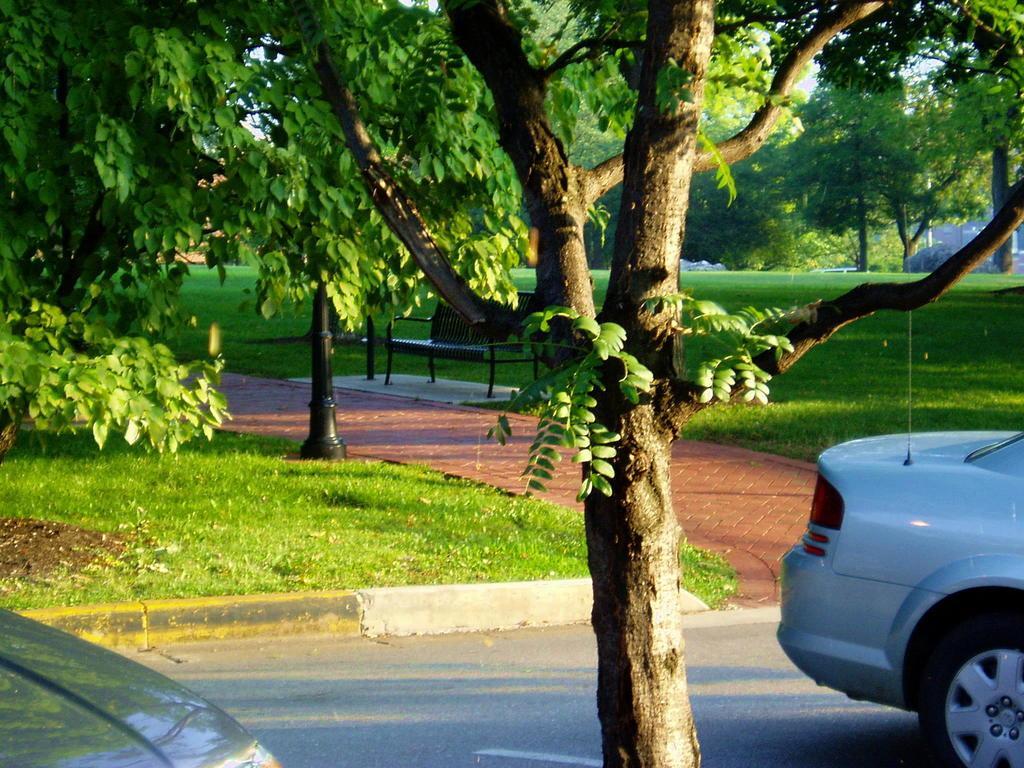In one or two sentences, can you explain what this image depicts? On the right side of the image we can see one car on the road. At the bottom left side of the image, we can see one object. In the background, we can see the grass, trees, one pole, bench and a few other objects. 